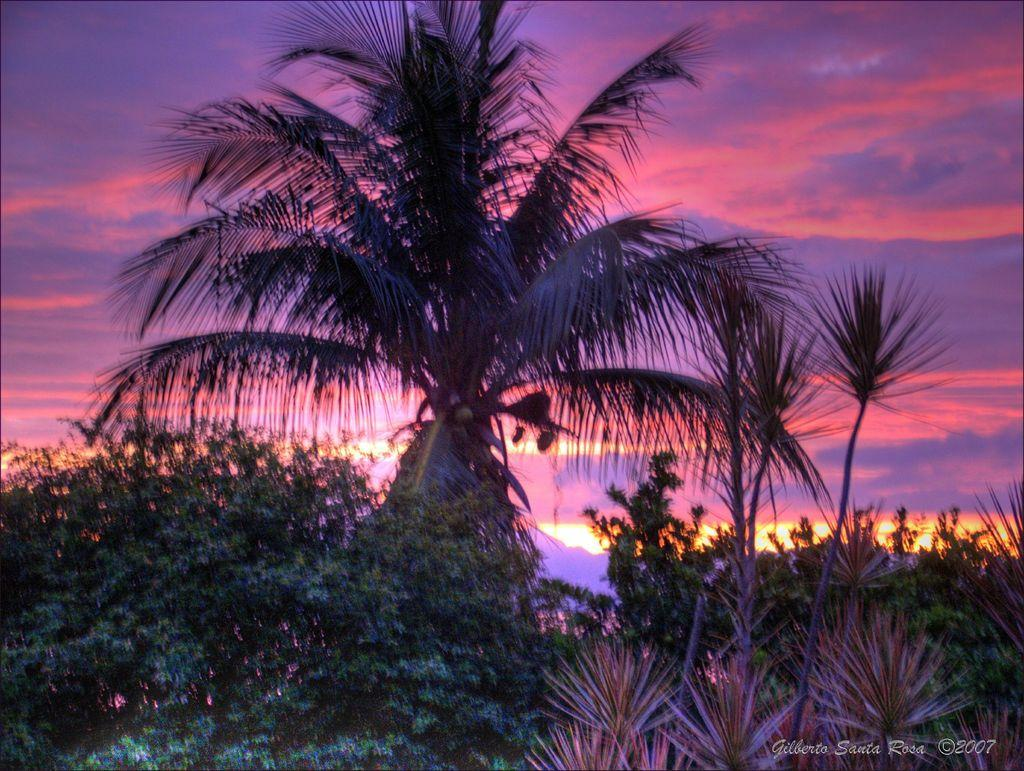What type of vegetation is in the foreground of the picture? There are trees in the foreground of the picture. Can you identify any specific type of tree in the picture? Yes, there is a coconut tree at the top of the picture. What can be seen in the sky in the picture? There are clouds in the sky. What type of kettle is hanging from the coconut tree in the image? There is no kettle present in the image; it only features trees and clouds. Can you describe the pain experienced by the cherries in the image? There are no cherries present in the image, so it is not possible to describe any pain they might be experiencing. 